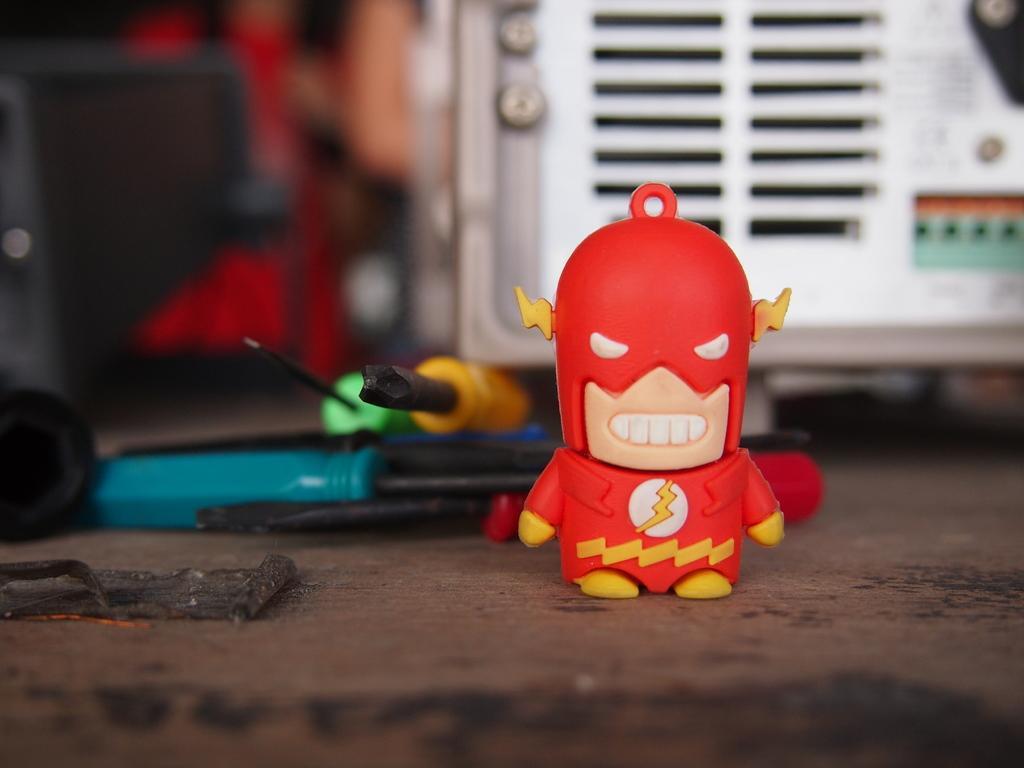Could you give a brief overview of what you see in this image? In this picture we can see a toy and screwdrivers on a platform and in the background it is blurry. 